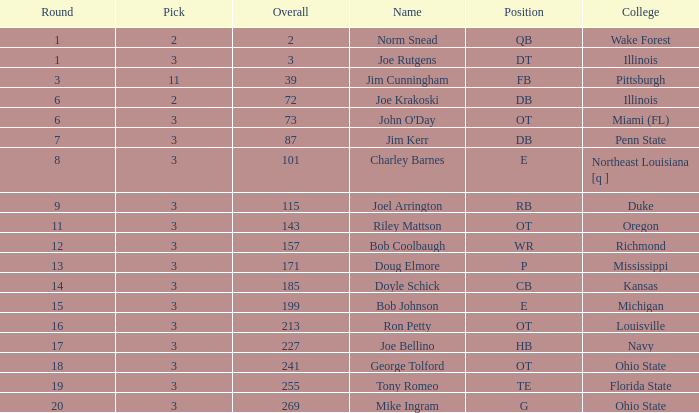How many overalls have charley barnes as the name, with a pick less than 3? None. 